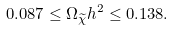Convert formula to latex. <formula><loc_0><loc_0><loc_500><loc_500>0 . 0 8 7 \leq \Omega _ { \widetilde { \chi } } h ^ { 2 } \leq 0 . 1 3 8 .</formula> 